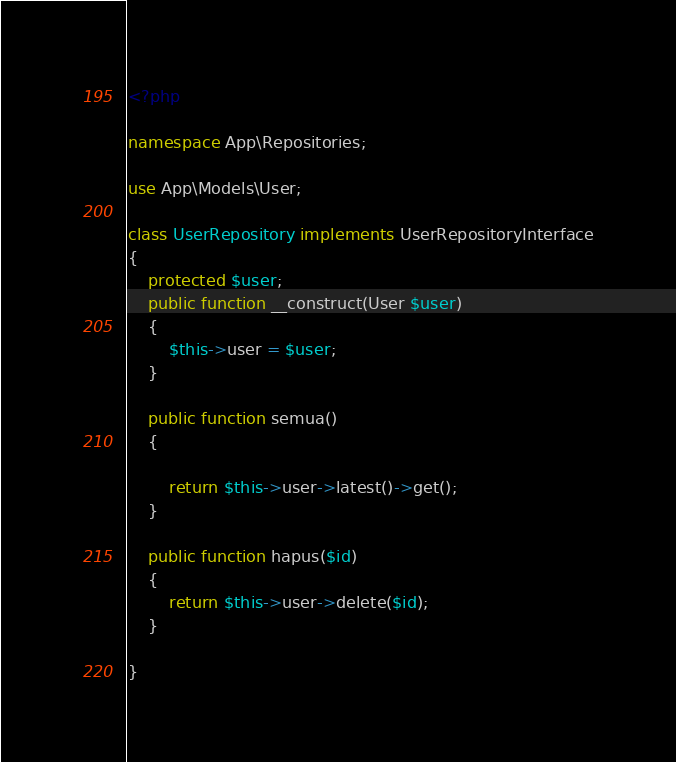<code> <loc_0><loc_0><loc_500><loc_500><_PHP_><?php

namespace App\Repositories;

use App\Models\User;

class UserRepository implements UserRepositoryInterface
{
    protected $user;
    public function __construct(User $user)
    {
        $this->user = $user;
    }

    public function semua()
    {

        return $this->user->latest()->get();
    }

    public function hapus($id)
    {
        return $this->user->delete($id);
    }

}
</code> 